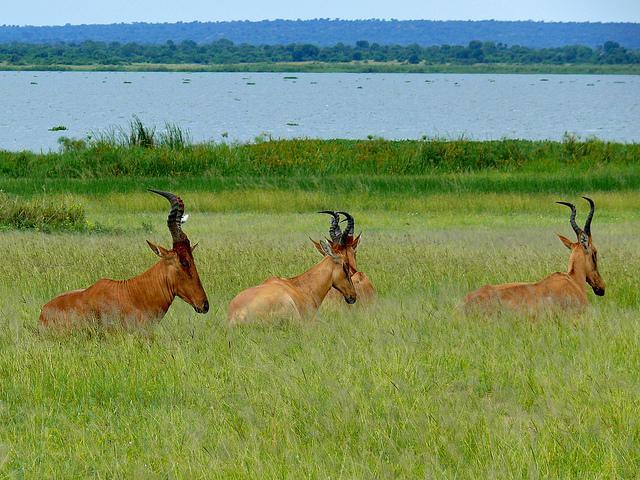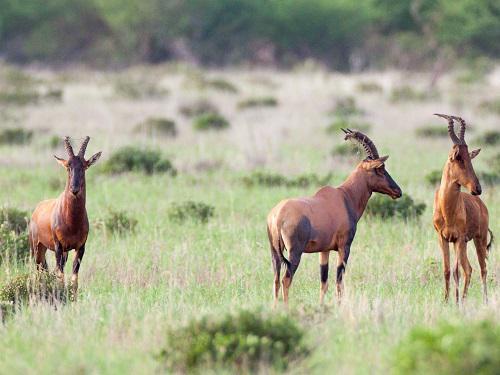The first image is the image on the left, the second image is the image on the right. For the images displayed, is the sentence "The right image contains no more than three antelope." factually correct? Answer yes or no. Yes. The first image is the image on the left, the second image is the image on the right. For the images displayed, is the sentence "There are no more than three animals in the image on the right." factually correct? Answer yes or no. Yes. 